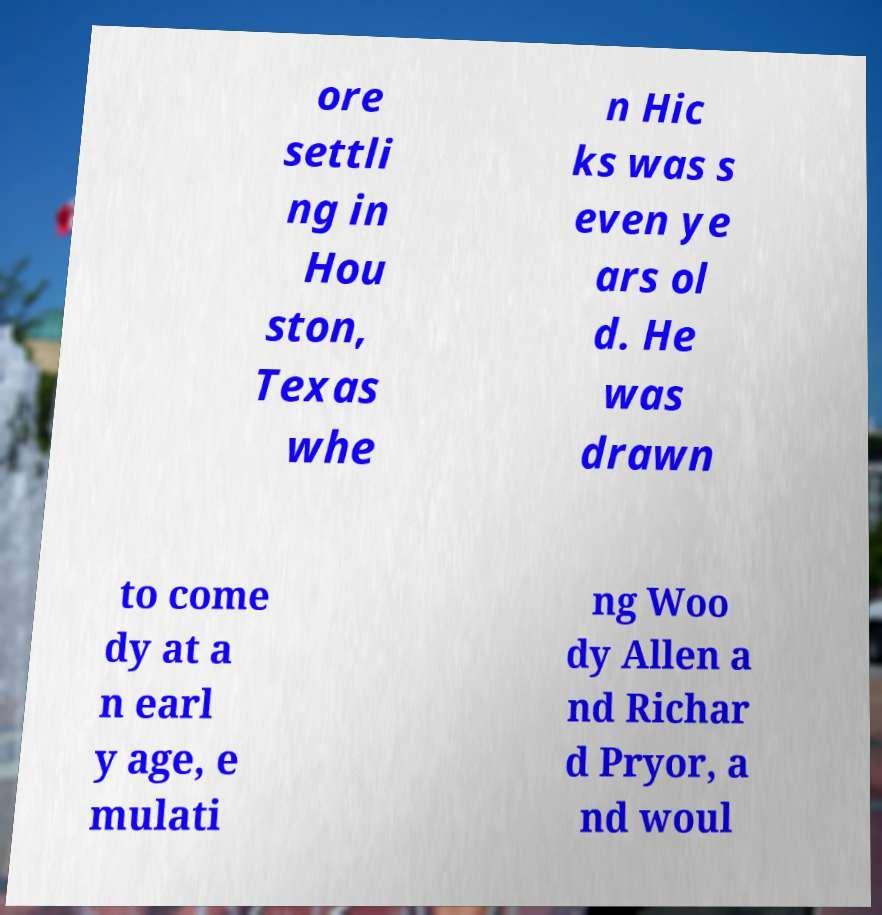For documentation purposes, I need the text within this image transcribed. Could you provide that? ore settli ng in Hou ston, Texas whe n Hic ks was s even ye ars ol d. He was drawn to come dy at a n earl y age, e mulati ng Woo dy Allen a nd Richar d Pryor, a nd woul 